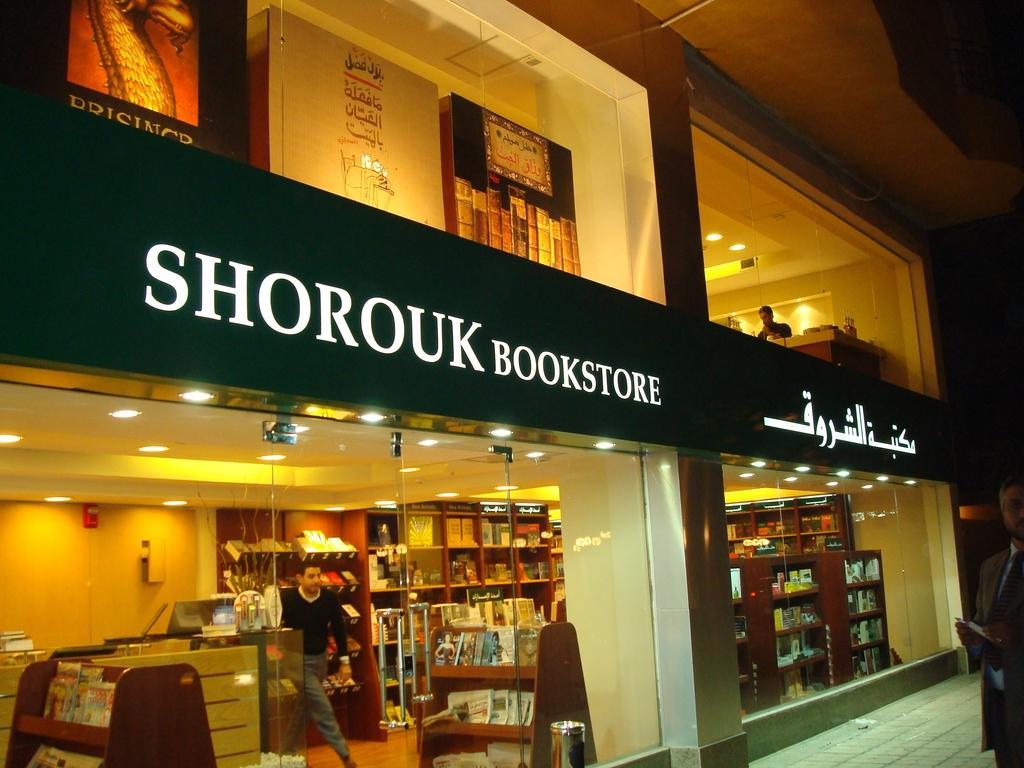Describe this image in one or two sentences. In this image we can see the bookstore. And we can see the glass windows. And we can see one person standing in the store. And we can see the books aligned in racks. And we can see some other objects. And we can see the lights. 